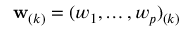<formula> <loc_0><loc_0><loc_500><loc_500>w _ { ( k ) } = ( w _ { 1 } , \dots , w _ { p } ) _ { ( k ) }</formula> 